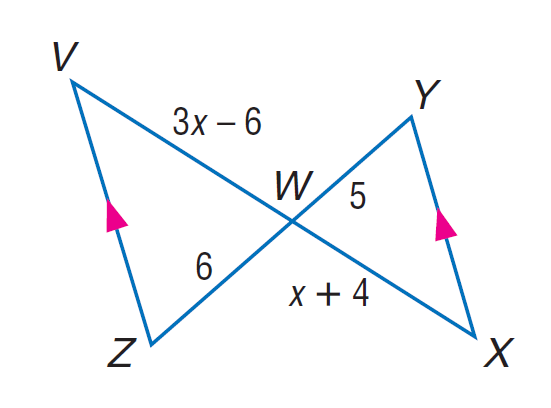Answer the mathemtical geometry problem and directly provide the correct option letter.
Question: Find W X.
Choices: A: 6 B: 8 C: 10 D: 12 C 